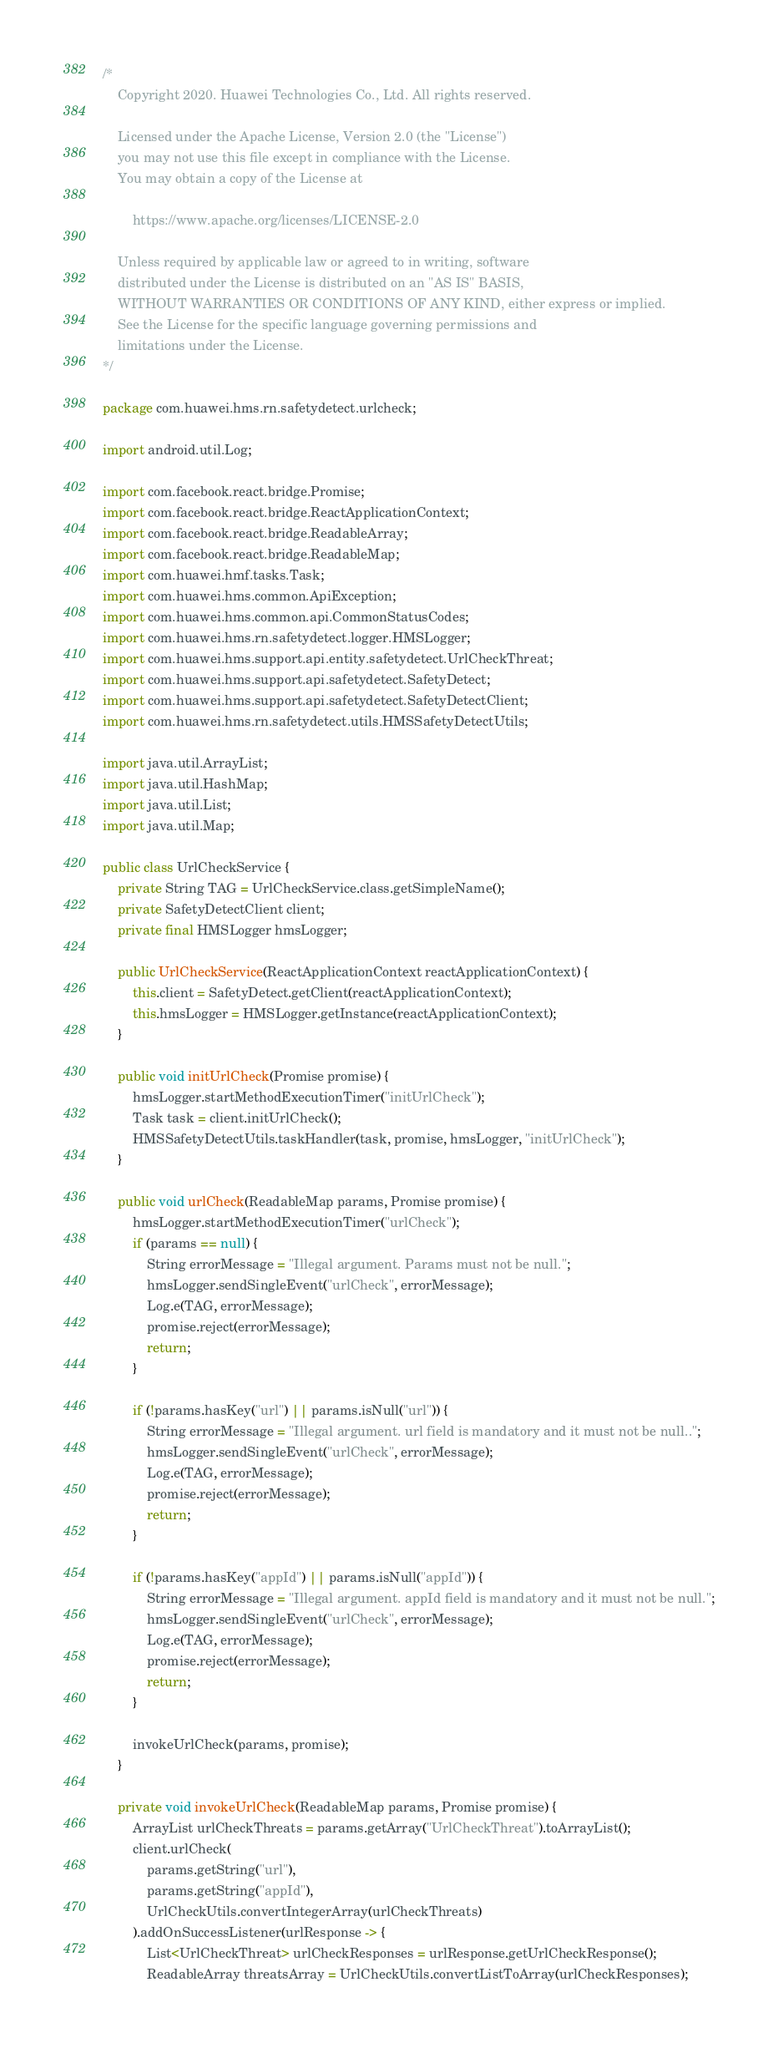Convert code to text. <code><loc_0><loc_0><loc_500><loc_500><_Java_>/*
    Copyright 2020. Huawei Technologies Co., Ltd. All rights reserved.

    Licensed under the Apache License, Version 2.0 (the "License")
    you may not use this file except in compliance with the License.
    You may obtain a copy of the License at

        https://www.apache.org/licenses/LICENSE-2.0

    Unless required by applicable law or agreed to in writing, software
    distributed under the License is distributed on an "AS IS" BASIS,
    WITHOUT WARRANTIES OR CONDITIONS OF ANY KIND, either express or implied.
    See the License for the specific language governing permissions and
    limitations under the License.
*/

package com.huawei.hms.rn.safetydetect.urlcheck;

import android.util.Log;

import com.facebook.react.bridge.Promise;
import com.facebook.react.bridge.ReactApplicationContext;
import com.facebook.react.bridge.ReadableArray;
import com.facebook.react.bridge.ReadableMap;
import com.huawei.hmf.tasks.Task;
import com.huawei.hms.common.ApiException;
import com.huawei.hms.common.api.CommonStatusCodes;
import com.huawei.hms.rn.safetydetect.logger.HMSLogger;
import com.huawei.hms.support.api.entity.safetydetect.UrlCheckThreat;
import com.huawei.hms.support.api.safetydetect.SafetyDetect;
import com.huawei.hms.support.api.safetydetect.SafetyDetectClient;
import com.huawei.hms.rn.safetydetect.utils.HMSSafetyDetectUtils;

import java.util.ArrayList;
import java.util.HashMap;
import java.util.List;
import java.util.Map;

public class UrlCheckService {
    private String TAG = UrlCheckService.class.getSimpleName();
    private SafetyDetectClient client;
    private final HMSLogger hmsLogger;

    public UrlCheckService(ReactApplicationContext reactApplicationContext) {
        this.client = SafetyDetect.getClient(reactApplicationContext);
        this.hmsLogger = HMSLogger.getInstance(reactApplicationContext);
    }

    public void initUrlCheck(Promise promise) {
        hmsLogger.startMethodExecutionTimer("initUrlCheck");
        Task task = client.initUrlCheck();
        HMSSafetyDetectUtils.taskHandler(task, promise, hmsLogger, "initUrlCheck");
    }

    public void urlCheck(ReadableMap params, Promise promise) {
        hmsLogger.startMethodExecutionTimer("urlCheck");
        if (params == null) {
            String errorMessage = "Illegal argument. Params must not be null.";
            hmsLogger.sendSingleEvent("urlCheck", errorMessage);
            Log.e(TAG, errorMessage);
            promise.reject(errorMessage);
            return;
        }

        if (!params.hasKey("url") || params.isNull("url")) {
            String errorMessage = "Illegal argument. url field is mandatory and it must not be null..";
            hmsLogger.sendSingleEvent("urlCheck", errorMessage);
            Log.e(TAG, errorMessage);
            promise.reject(errorMessage);
            return;
        }

        if (!params.hasKey("appId") || params.isNull("appId")) {
            String errorMessage = "Illegal argument. appId field is mandatory and it must not be null.";
            hmsLogger.sendSingleEvent("urlCheck", errorMessage);
            Log.e(TAG, errorMessage);
            promise.reject(errorMessage);
            return;
        }

        invokeUrlCheck(params, promise);
    }

    private void invokeUrlCheck(ReadableMap params, Promise promise) {
        ArrayList urlCheckThreats = params.getArray("UrlCheckThreat").toArrayList();
        client.urlCheck(
            params.getString("url"),
            params.getString("appId"),
            UrlCheckUtils.convertIntegerArray(urlCheckThreats)
        ).addOnSuccessListener(urlResponse -> {
            List<UrlCheckThreat> urlCheckResponses = urlResponse.getUrlCheckResponse();
            ReadableArray threatsArray = UrlCheckUtils.convertListToArray(urlCheckResponses);</code> 